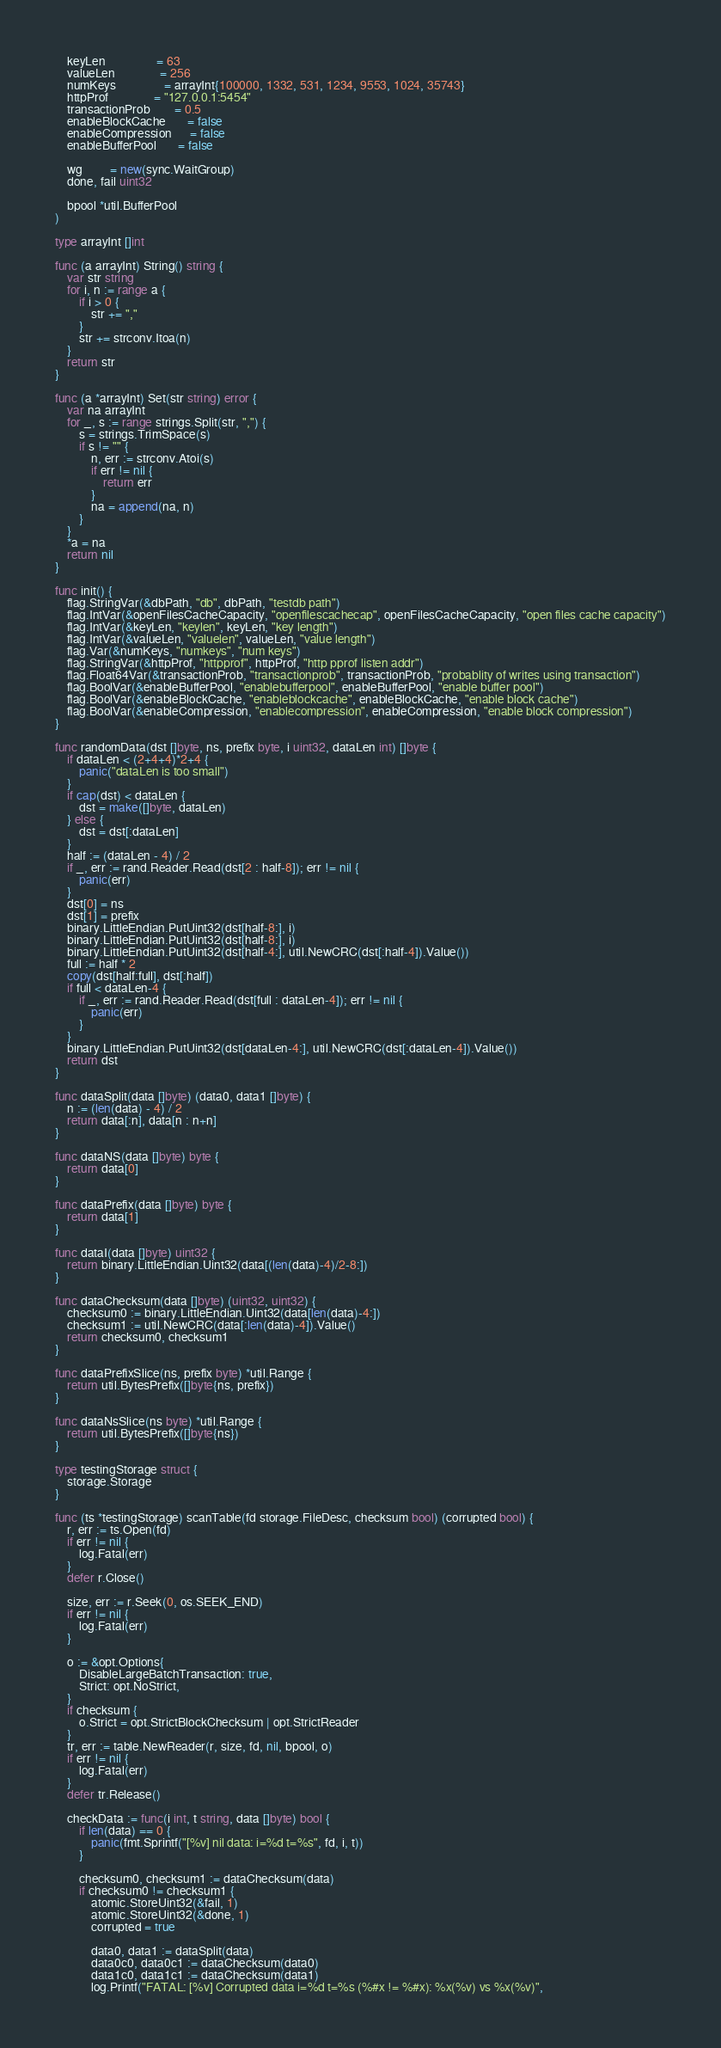<code> <loc_0><loc_0><loc_500><loc_500><_Go_>	keyLen                 = 63
	valueLen               = 256
	numKeys                = arrayInt{100000, 1332, 531, 1234, 9553, 1024, 35743}
	httpProf               = "127.0.0.1:5454"
	transactionProb        = 0.5
	enableBlockCache       = false
	enableCompression      = false
	enableBufferPool       = false

	wg         = new(sync.WaitGroup)
	done, fail uint32

	bpool *util.BufferPool
)

type arrayInt []int

func (a arrayInt) String() string {
	var str string
	for i, n := range a {
		if i > 0 {
			str += ","
		}
		str += strconv.Itoa(n)
	}
	return str
}

func (a *arrayInt) Set(str string) error {
	var na arrayInt
	for _, s := range strings.Split(str, ",") {
		s = strings.TrimSpace(s)
		if s != "" {
			n, err := strconv.Atoi(s)
			if err != nil {
				return err
			}
			na = append(na, n)
		}
	}
	*a = na
	return nil
}

func init() {
	flag.StringVar(&dbPath, "db", dbPath, "testdb path")
	flag.IntVar(&openFilesCacheCapacity, "openfilescachecap", openFilesCacheCapacity, "open files cache capacity")
	flag.IntVar(&keyLen, "keylen", keyLen, "key length")
	flag.IntVar(&valueLen, "valuelen", valueLen, "value length")
	flag.Var(&numKeys, "numkeys", "num keys")
	flag.StringVar(&httpProf, "httpprof", httpProf, "http pprof listen addr")
	flag.Float64Var(&transactionProb, "transactionprob", transactionProb, "probablity of writes using transaction")
	flag.BoolVar(&enableBufferPool, "enablebufferpool", enableBufferPool, "enable buffer pool")
	flag.BoolVar(&enableBlockCache, "enableblockcache", enableBlockCache, "enable block cache")
	flag.BoolVar(&enableCompression, "enablecompression", enableCompression, "enable block compression")
}

func randomData(dst []byte, ns, prefix byte, i uint32, dataLen int) []byte {
	if dataLen < (2+4+4)*2+4 {
		panic("dataLen is too small")
	}
	if cap(dst) < dataLen {
		dst = make([]byte, dataLen)
	} else {
		dst = dst[:dataLen]
	}
	half := (dataLen - 4) / 2
	if _, err := rand.Reader.Read(dst[2 : half-8]); err != nil {
		panic(err)
	}
	dst[0] = ns
	dst[1] = prefix
	binary.LittleEndian.PutUint32(dst[half-8:], i)
	binary.LittleEndian.PutUint32(dst[half-8:], i)
	binary.LittleEndian.PutUint32(dst[half-4:], util.NewCRC(dst[:half-4]).Value())
	full := half * 2
	copy(dst[half:full], dst[:half])
	if full < dataLen-4 {
		if _, err := rand.Reader.Read(dst[full : dataLen-4]); err != nil {
			panic(err)
		}
	}
	binary.LittleEndian.PutUint32(dst[dataLen-4:], util.NewCRC(dst[:dataLen-4]).Value())
	return dst
}

func dataSplit(data []byte) (data0, data1 []byte) {
	n := (len(data) - 4) / 2
	return data[:n], data[n : n+n]
}

func dataNS(data []byte) byte {
	return data[0]
}

func dataPrefix(data []byte) byte {
	return data[1]
}

func dataI(data []byte) uint32 {
	return binary.LittleEndian.Uint32(data[(len(data)-4)/2-8:])
}

func dataChecksum(data []byte) (uint32, uint32) {
	checksum0 := binary.LittleEndian.Uint32(data[len(data)-4:])
	checksum1 := util.NewCRC(data[:len(data)-4]).Value()
	return checksum0, checksum1
}

func dataPrefixSlice(ns, prefix byte) *util.Range {
	return util.BytesPrefix([]byte{ns, prefix})
}

func dataNsSlice(ns byte) *util.Range {
	return util.BytesPrefix([]byte{ns})
}

type testingStorage struct {
	storage.Storage
}

func (ts *testingStorage) scanTable(fd storage.FileDesc, checksum bool) (corrupted bool) {
	r, err := ts.Open(fd)
	if err != nil {
		log.Fatal(err)
	}
	defer r.Close()

	size, err := r.Seek(0, os.SEEK_END)
	if err != nil {
		log.Fatal(err)
	}

	o := &opt.Options{
		DisableLargeBatchTransaction: true,
		Strict: opt.NoStrict,
	}
	if checksum {
		o.Strict = opt.StrictBlockChecksum | opt.StrictReader
	}
	tr, err := table.NewReader(r, size, fd, nil, bpool, o)
	if err != nil {
		log.Fatal(err)
	}
	defer tr.Release()

	checkData := func(i int, t string, data []byte) bool {
		if len(data) == 0 {
			panic(fmt.Sprintf("[%v] nil data: i=%d t=%s", fd, i, t))
		}

		checksum0, checksum1 := dataChecksum(data)
		if checksum0 != checksum1 {
			atomic.StoreUint32(&fail, 1)
			atomic.StoreUint32(&done, 1)
			corrupted = true

			data0, data1 := dataSplit(data)
			data0c0, data0c1 := dataChecksum(data0)
			data1c0, data1c1 := dataChecksum(data1)
			log.Printf("FATAL: [%v] Corrupted data i=%d t=%s (%#x != %#x): %x(%v) vs %x(%v)",</code> 